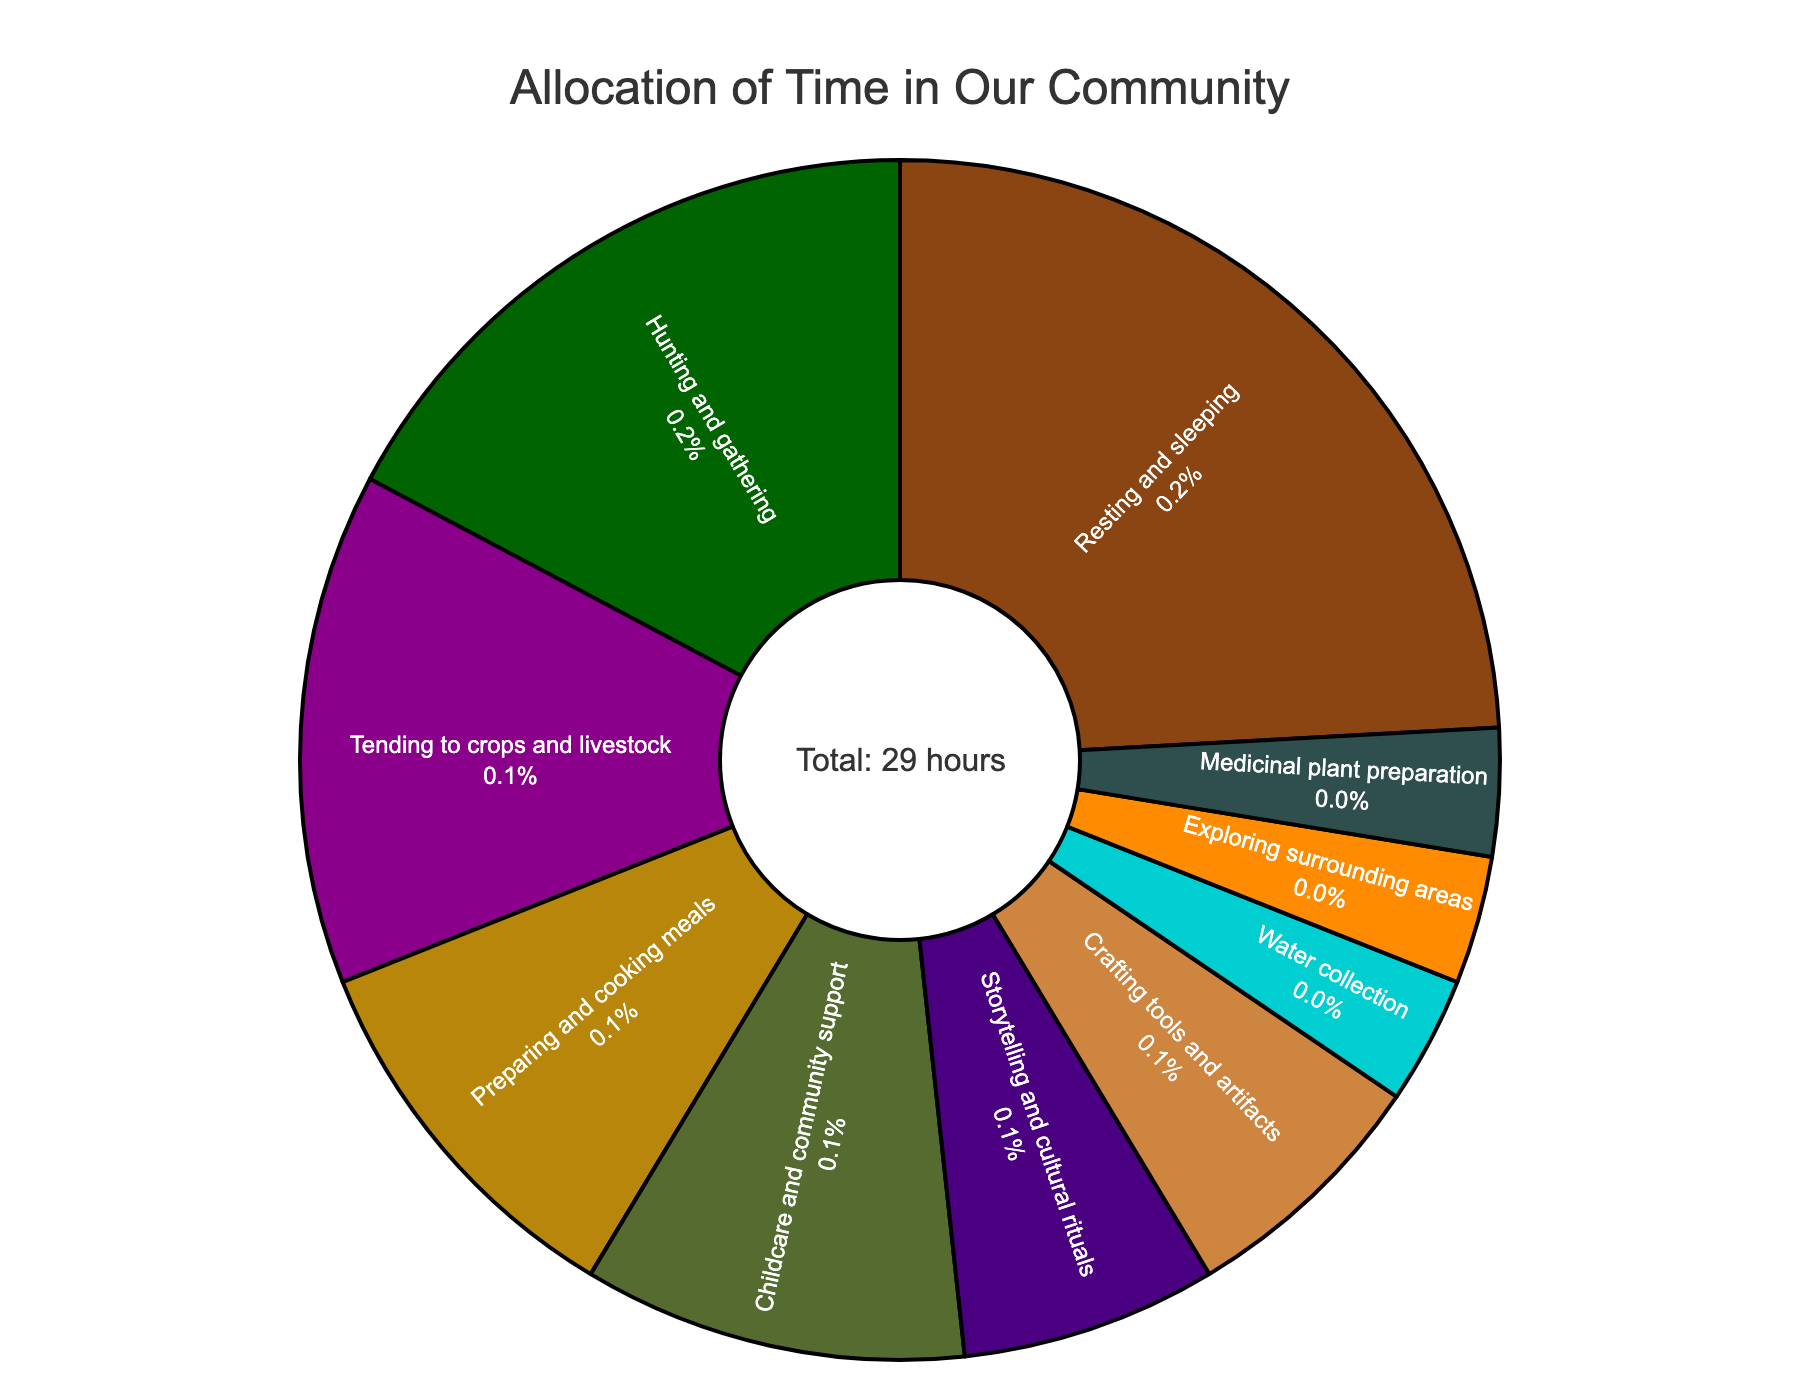What percentage of time is spent on resting and sleeping? Locate the section labeled "Resting and sleeping" in the pie chart. The chart indicates that resting and sleeping take up 24.1% of the total time.
Answer: 24.1% Which activity takes up the least amount of time? Examine the pie chart and identify the slice representing the smallest percentage. "Medicinal plant preparation," "Exploring surrounding areas," and "Water collection" each take up 3.4%, the lowest percentage.
Answer: Medicinal plant preparation, Exploring surrounding areas, Water collection How much more time is spent hunting and gathering compared to storytelling and cultural rituals? Find the percentages for hunting and gathering (17.2%) and storytelling and cultural rituals (6.9%). Calculate the difference: 17.2% - 6.9% = 10.3%.
Answer: 10.3% What are the two activities with the highest percentages of time allocation? Identify the largest slices on the pie chart. The activities with the highest percentages are "Resting and sleeping" (24.1%) and "Hunting and gathering" (17.2%).
Answer: Resting and sleeping, Hunting and gathering How many hours are dedicated to childcare and community support? Refer to the pie chart to find the percentage for "Childcare and community support" (10.3%). Multiply this percentage by the total number of hours (29): 10.3% of 29 ≈ 3 hours.
Answer: 3 hours Compare the total percentage of time spent on preparing and cooking meals and tending to crops and livestock. Find the percentages for "Preparing and cooking meals" (10.3%) and "Tending to crops and livestock" (13.8%) and calculate the total: 10.3% + 13.8% = 24.1%.
Answer: 24.1% What percentage of time is spent on both crafting tools and artifacts and water collection combined? Locate the sections for "Crafting tools and artifacts" (6.9%) and "Water collection" (3.4%). Sum the percentages: 6.9% + 3.4% = 10.3%.
Answer: 10.3% How much less time is spent on exploring surrounding areas than tending to crops and livestock? Compare the percentages for "Exploring surrounding areas" (3.4%) and "Tending to crops and livestock" (13.8%). Calculate the difference: 13.8% - 3.4% = 10.4%.
Answer: 10.4% 